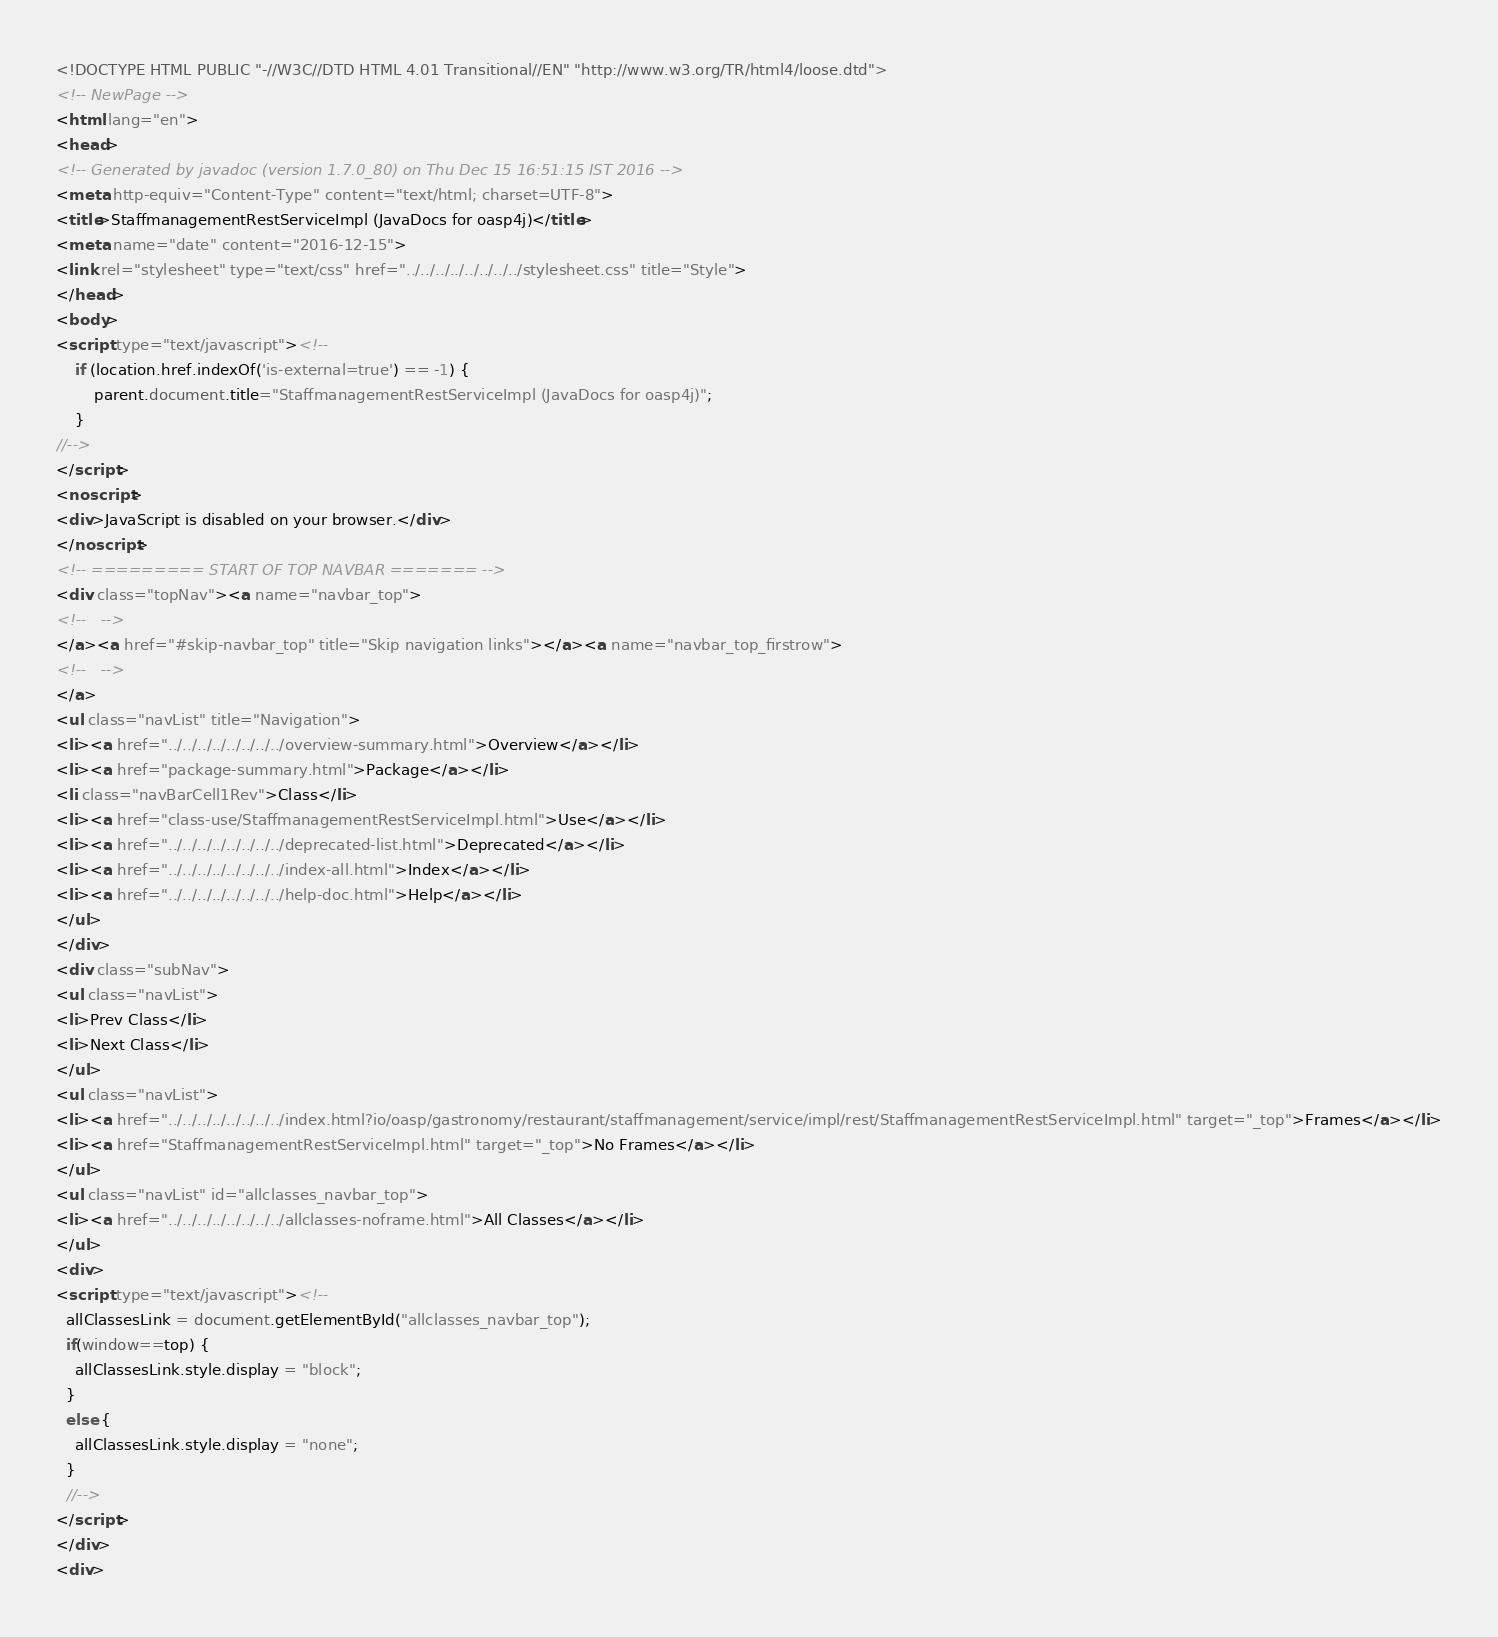<code> <loc_0><loc_0><loc_500><loc_500><_HTML_><!DOCTYPE HTML PUBLIC "-//W3C//DTD HTML 4.01 Transitional//EN" "http://www.w3.org/TR/html4/loose.dtd">
<!-- NewPage -->
<html lang="en">
<head>
<!-- Generated by javadoc (version 1.7.0_80) on Thu Dec 15 16:51:15 IST 2016 -->
<meta http-equiv="Content-Type" content="text/html; charset=UTF-8">
<title>StaffmanagementRestServiceImpl (JavaDocs for oasp4j)</title>
<meta name="date" content="2016-12-15">
<link rel="stylesheet" type="text/css" href="../../../../../../../../stylesheet.css" title="Style">
</head>
<body>
<script type="text/javascript"><!--
    if (location.href.indexOf('is-external=true') == -1) {
        parent.document.title="StaffmanagementRestServiceImpl (JavaDocs for oasp4j)";
    }
//-->
</script>
<noscript>
<div>JavaScript is disabled on your browser.</div>
</noscript>
<!-- ========= START OF TOP NAVBAR ======= -->
<div class="topNav"><a name="navbar_top">
<!--   -->
</a><a href="#skip-navbar_top" title="Skip navigation links"></a><a name="navbar_top_firstrow">
<!--   -->
</a>
<ul class="navList" title="Navigation">
<li><a href="../../../../../../../../overview-summary.html">Overview</a></li>
<li><a href="package-summary.html">Package</a></li>
<li class="navBarCell1Rev">Class</li>
<li><a href="class-use/StaffmanagementRestServiceImpl.html">Use</a></li>
<li><a href="../../../../../../../../deprecated-list.html">Deprecated</a></li>
<li><a href="../../../../../../../../index-all.html">Index</a></li>
<li><a href="../../../../../../../../help-doc.html">Help</a></li>
</ul>
</div>
<div class="subNav">
<ul class="navList">
<li>Prev Class</li>
<li>Next Class</li>
</ul>
<ul class="navList">
<li><a href="../../../../../../../../index.html?io/oasp/gastronomy/restaurant/staffmanagement/service/impl/rest/StaffmanagementRestServiceImpl.html" target="_top">Frames</a></li>
<li><a href="StaffmanagementRestServiceImpl.html" target="_top">No Frames</a></li>
</ul>
<ul class="navList" id="allclasses_navbar_top">
<li><a href="../../../../../../../../allclasses-noframe.html">All Classes</a></li>
</ul>
<div>
<script type="text/javascript"><!--
  allClassesLink = document.getElementById("allclasses_navbar_top");
  if(window==top) {
    allClassesLink.style.display = "block";
  }
  else {
    allClassesLink.style.display = "none";
  }
  //-->
</script>
</div>
<div></code> 